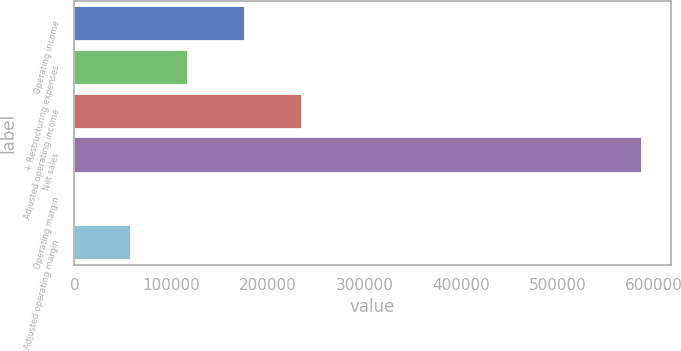<chart> <loc_0><loc_0><loc_500><loc_500><bar_chart><fcel>Operating income<fcel>+ Restructuring expenses<fcel>Adjusted operating income<fcel>Net sales<fcel>Operating margin<fcel>Adjusted operating margin<nl><fcel>176277<fcel>117527<fcel>235028<fcel>587533<fcel>25<fcel>58775.8<nl></chart> 